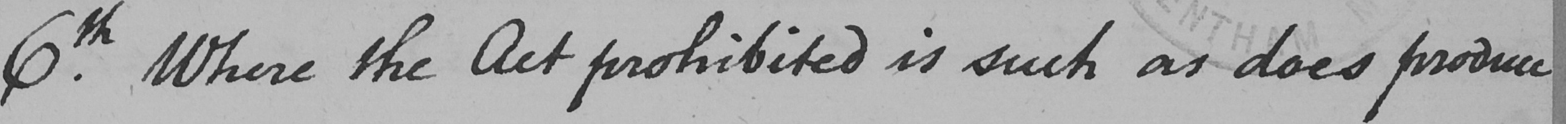Can you tell me what this handwritten text says? 6.th Where the Act prohibited is such as does produce 